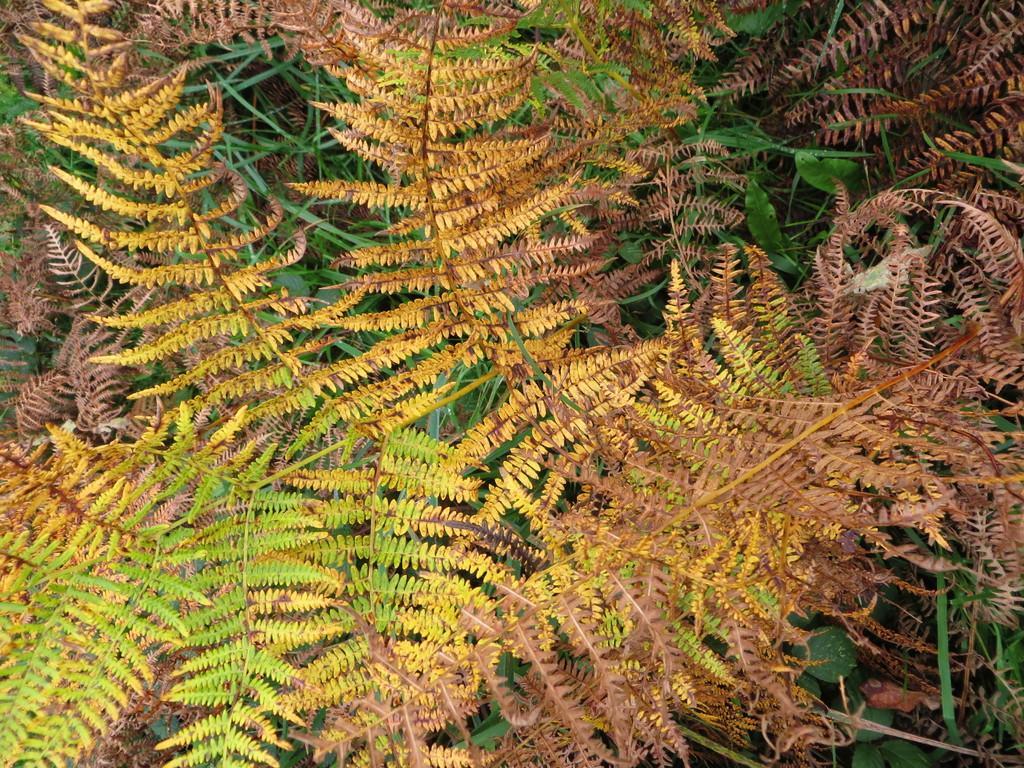Describe this image in one or two sentences. In this image, I think these are the trees with the stems and the leaves. 